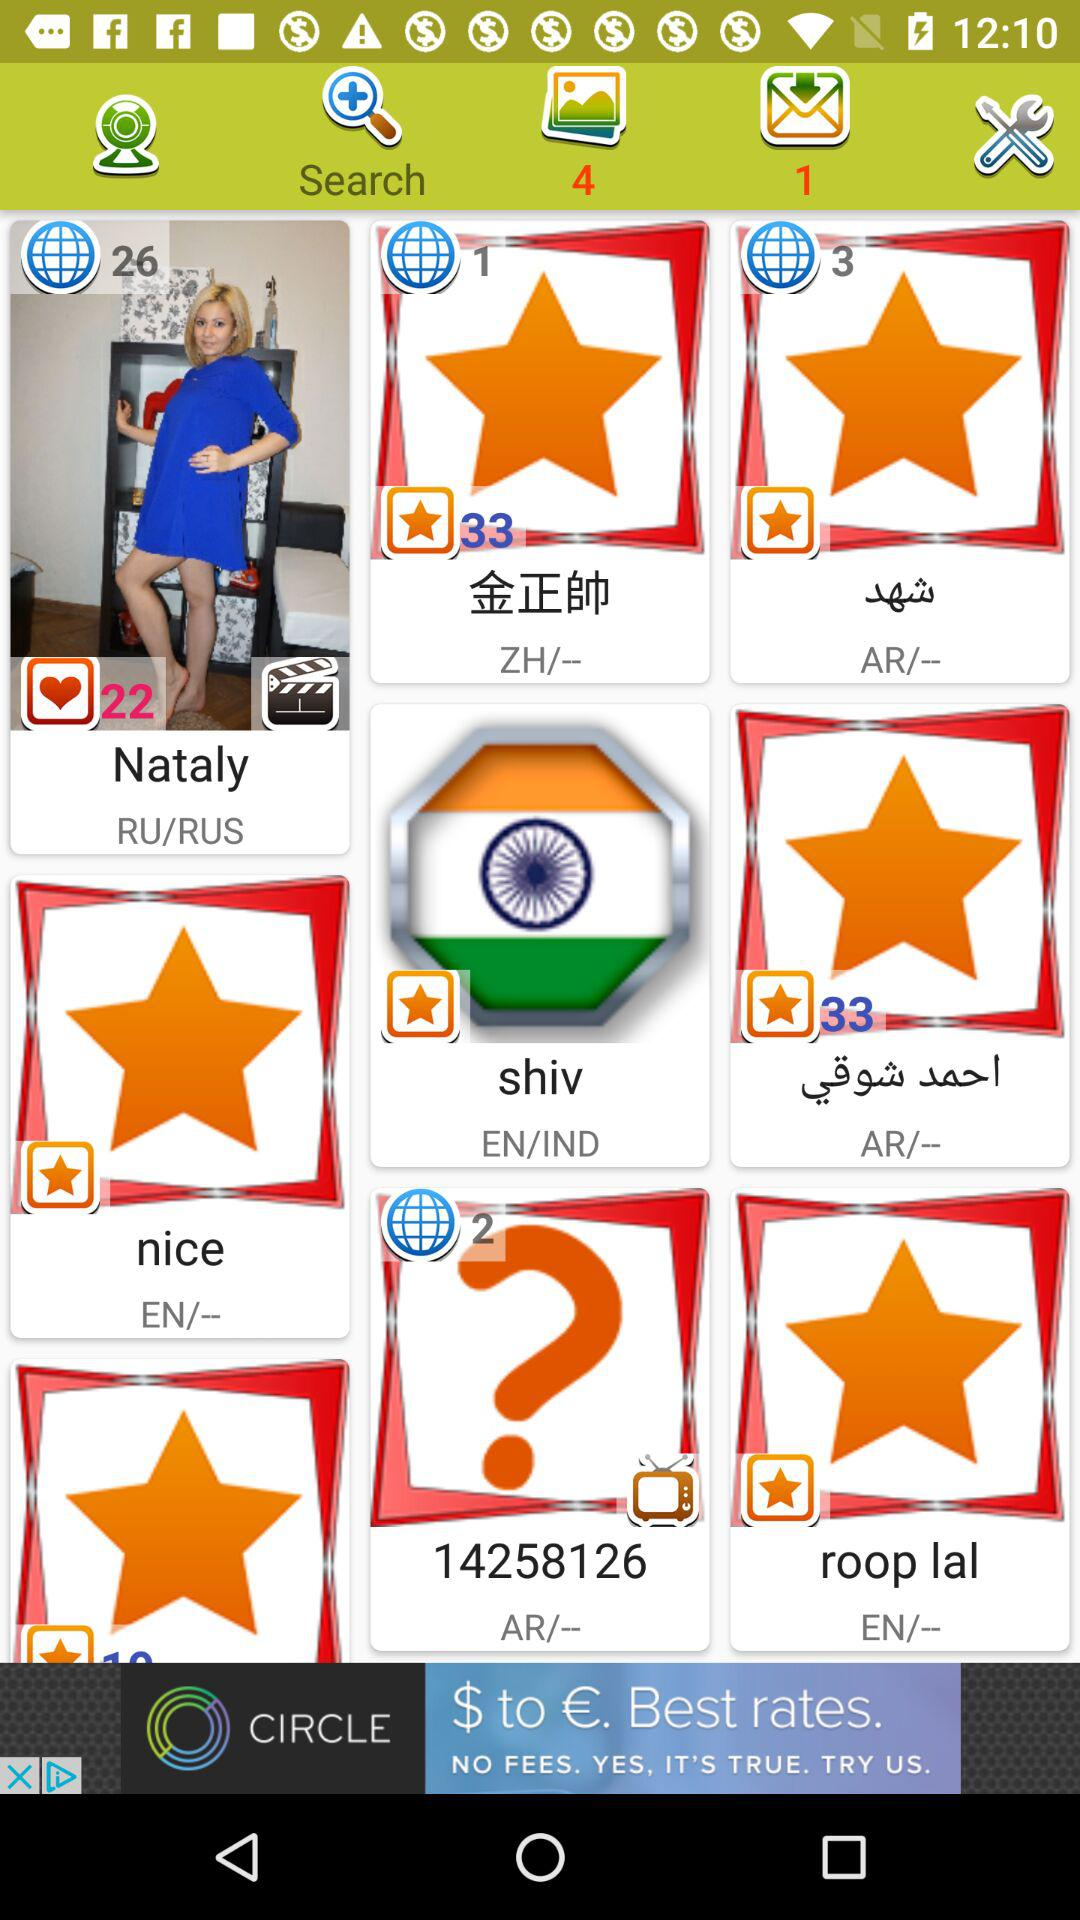What is the age of Nataly? Nataly is 22 years old. 